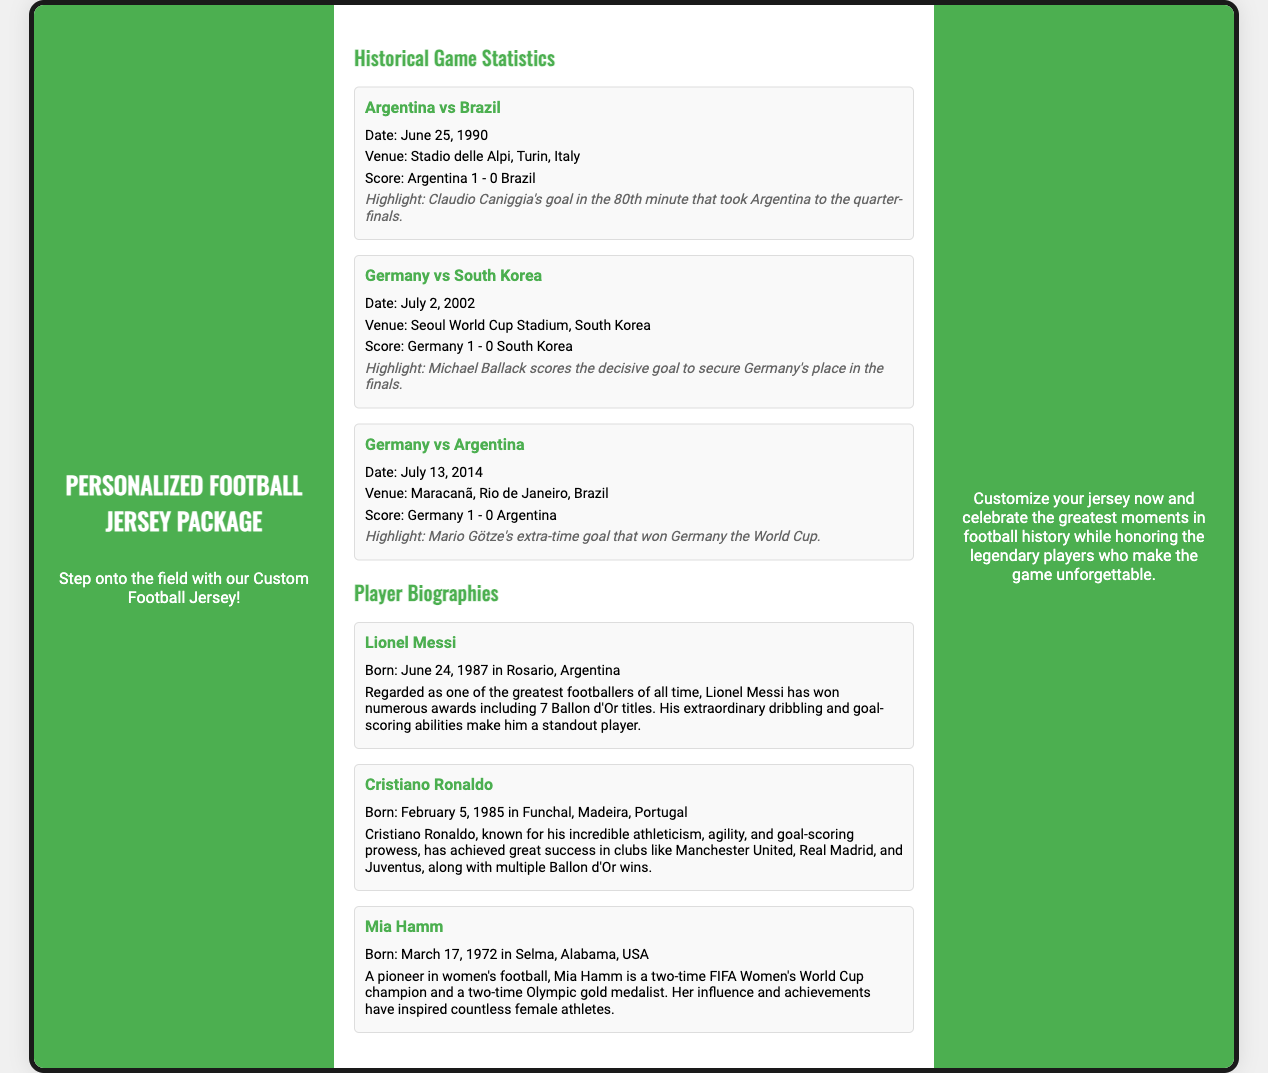what is the title of this document? The title is presented at the top of the document, which is "Personalized Football Jersey Package."
Answer: Personalized Football Jersey Package who scored the highlight goal in the Argentina vs Brazil match? The highlight mentions that Claudio Caniggia scored the goal that took Argentina to the quarter-finals.
Answer: Claudio Caniggia what is the venue for the Germany vs Argentina match? The venue is specified in the game statistics section, which states it took place at Maracanã, Rio de Janeiro, Brazil.
Answer: Maracanã, Rio de Janeiro, Brazil how many Ballon d'Or titles has Lionel Messi won? The document states that Lionel Messi has won numerous awards including 7 Ballon d'Or titles.
Answer: 7 which player is described as a pioneer in women's football? The player biography section provides information about Mia Hamm, who is regarded as a pioneer in women's football.
Answer: Mia Hamm what is the date of the Germany vs South Korea match? The document specifies the date of the match in the historical game statistics as July 2, 2002.
Answer: July 2, 2002 how many FIFA Women's World Cups has Mia Hamm won? The biography mentions that Mia Hamm is a two-time FIFA Women's World Cup champion.
Answer: Two what kind of packaging is this document describing? The document describes a packaging for a custom football jersey that includes historical game statistics and player biographies.
Answer: Custom Football Jersey Packaging 